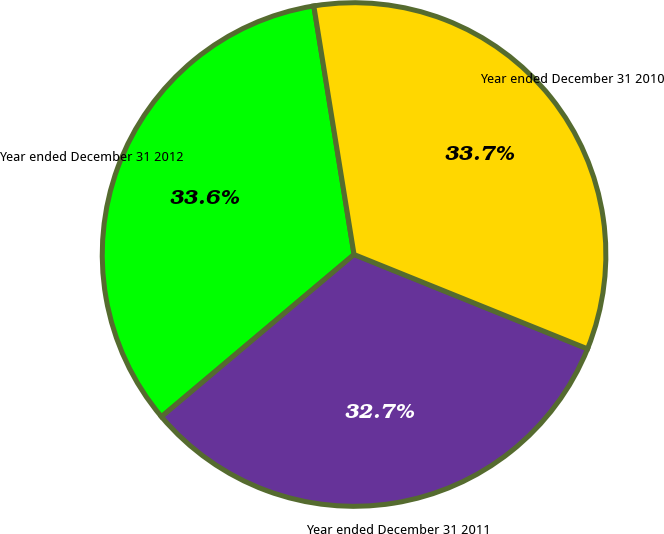Convert chart to OTSL. <chart><loc_0><loc_0><loc_500><loc_500><pie_chart><fcel>Year ended December 31 2012<fcel>Year ended December 31 2011<fcel>Year ended December 31 2010<nl><fcel>33.59%<fcel>32.75%<fcel>33.67%<nl></chart> 